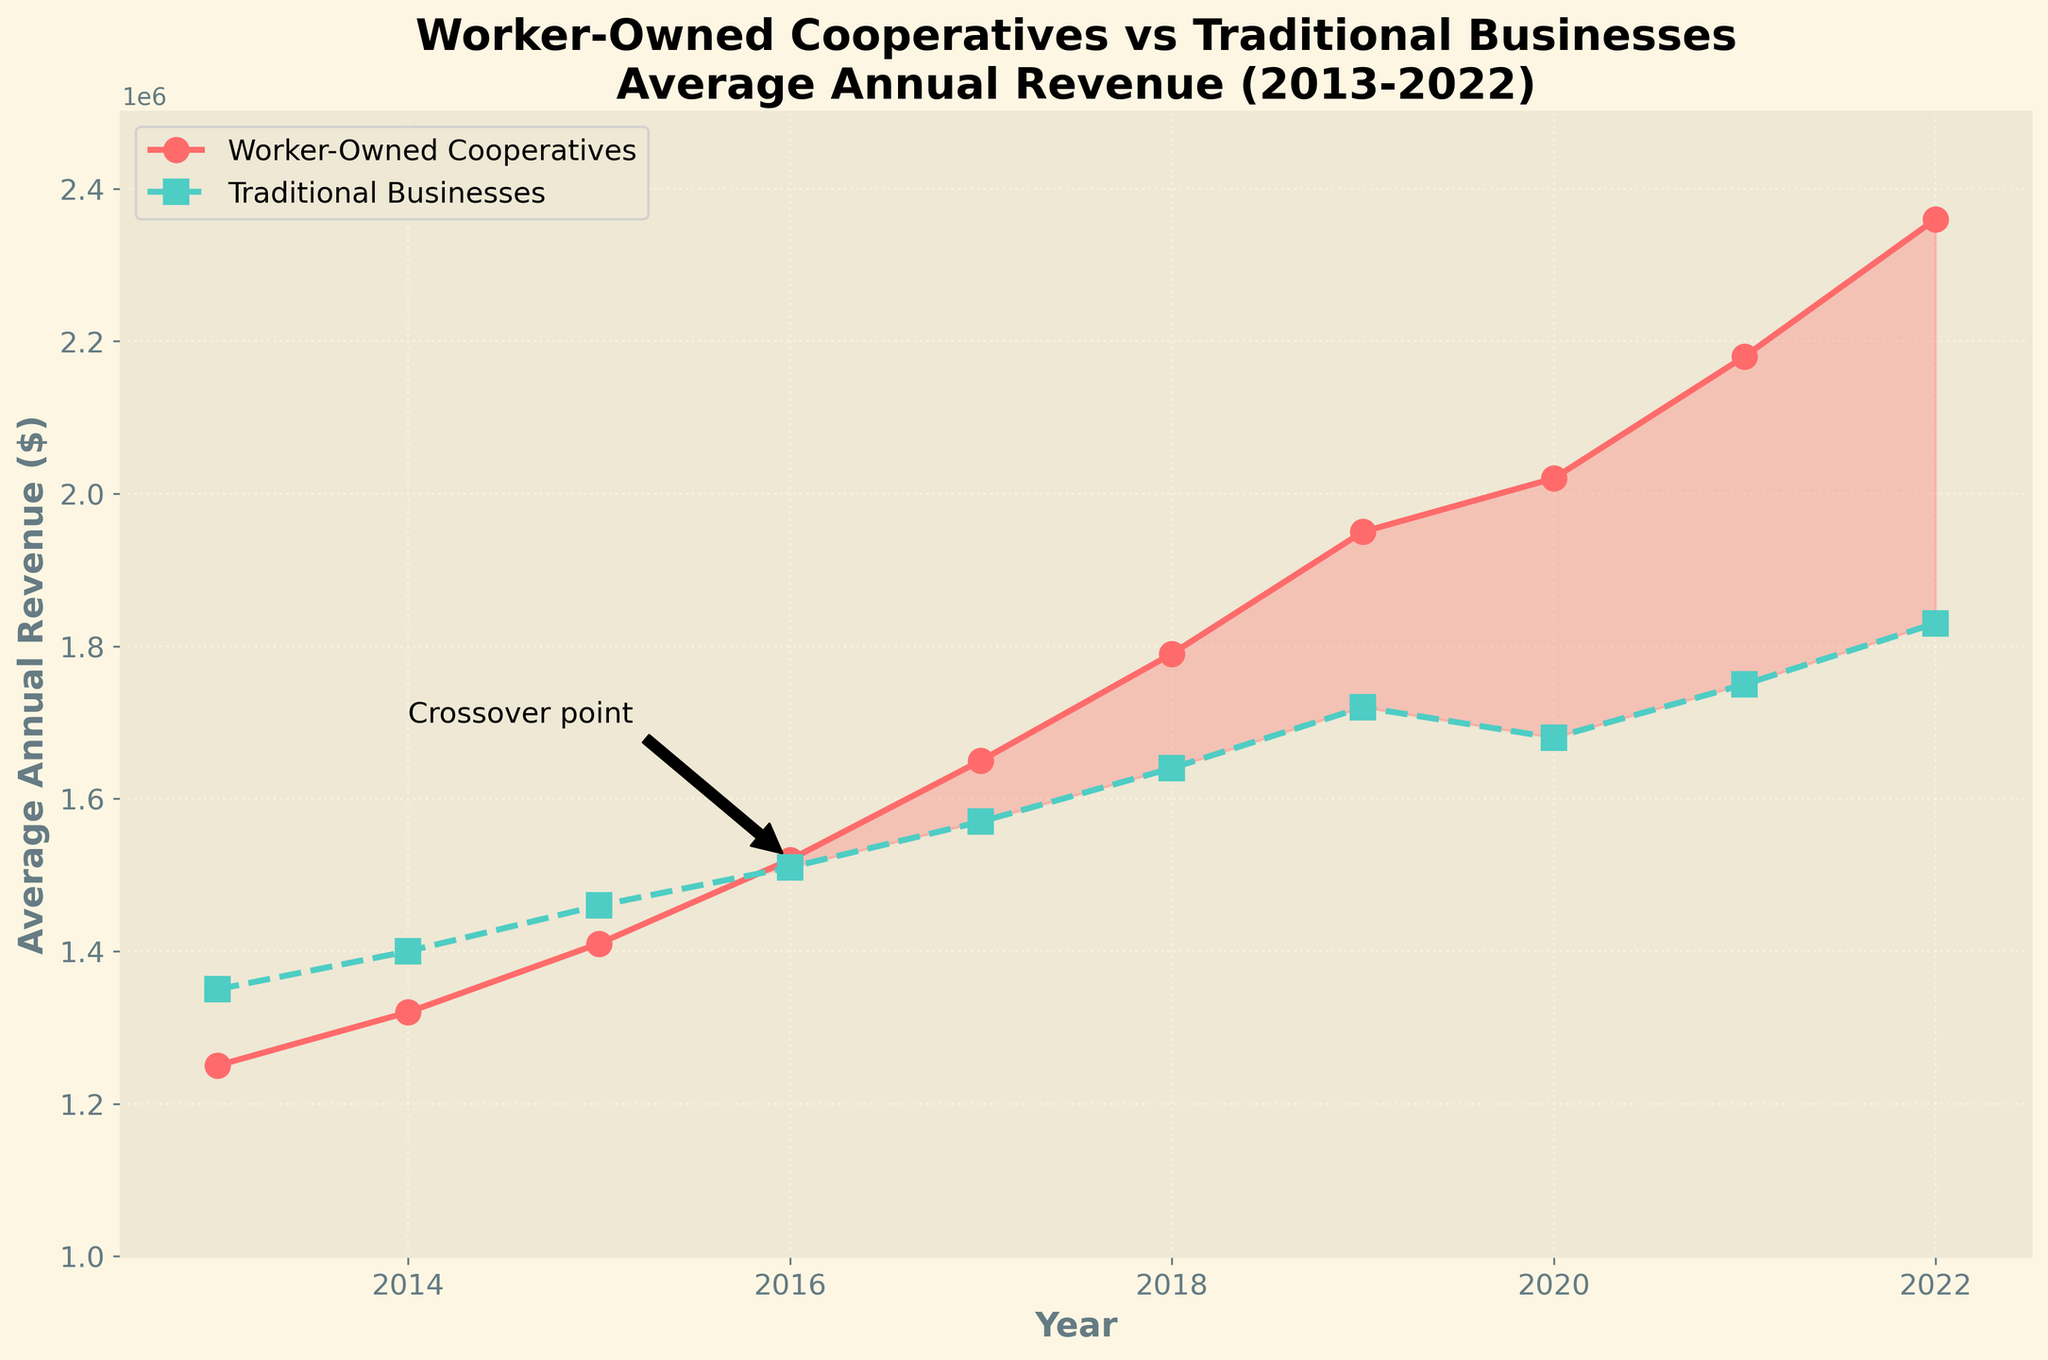What's the first year when the average revenue of worker-owned cooperatives exceeded traditional businesses? Look for the year where the line representing worker-owned cooperatives crosses above the line of traditional businesses. This happens in 2016.
Answer: 2016 In what year did worker-owned cooperatives have the highest average annual revenue during the period? Identify the point on the red line (cooperatives) with the highest value. This is at the end of the period in 2022.
Answer: 2022 By how much did the average annual revenue of worker-owned cooperatives grow from 2013 to 2022? Subtract the value for cooperatives in 2013 from the value in 2022. This is 2,360,000 - 1,250,000.
Answer: 1,110,000 Is there any point where the average revenue of traditional businesses decreased? Check for any year-to-year drops in the green line (traditional businesses). The revenue decreased from 2019 to 2020.
Answer: Yes For which years did the average annual revenue of worker-owned cooperatives exceed that of traditional businesses? Look for the years where the red line (cooperatives) is above the green line (traditional businesses). This is from 2016 onwards.
Answer: 2016-2022 What's the average revenue of worker-owned cooperatives over the 10-year period? Sum up the revenues for each year from 2013 to 2022 and divide by the number of years (10). (1,250,000 + 1,320,000 + 1,410,000 + 1,520,000 + 1,650,000 + 1,790,000 + 1,950,000 + 2,020,000 + 2,180,000 + 2,360,000) / 10.
Answer: 1,745,000 Which business type had a higher growth rate in annual revenue over the 10-year period? Calculate the percentage increase for both cooperatives and traditional businesses and compare. [(2,360,000 - 1,250,000) / 1,250,000] for cooperatives and [(1,830,000 - 1,350,000) / 1,350,000] for traditional businesses. The percentage increase for cooperatives is about 88.8%, and for traditional businesses, it is about 35.6%.
Answer: Worker-owned cooperatives During which year was the gap between the revenues of the two business types the largest? Look for the largest vertical distance between the red and green lines. This occurs in 2022.
Answer: 2022 What is the approximate revenue difference between the two business types in 2018? Subtract the revenue of traditional businesses in 2018 from that of cooperatives. 1,790,000 - 1,640,000.
Answer: 150,000 Is there a year when the average revenue of both business types was equal or nearly equal? Check if there is a point where the red and green lines overlap or nearly overlap. This happens in 2016.
Answer: 2016 